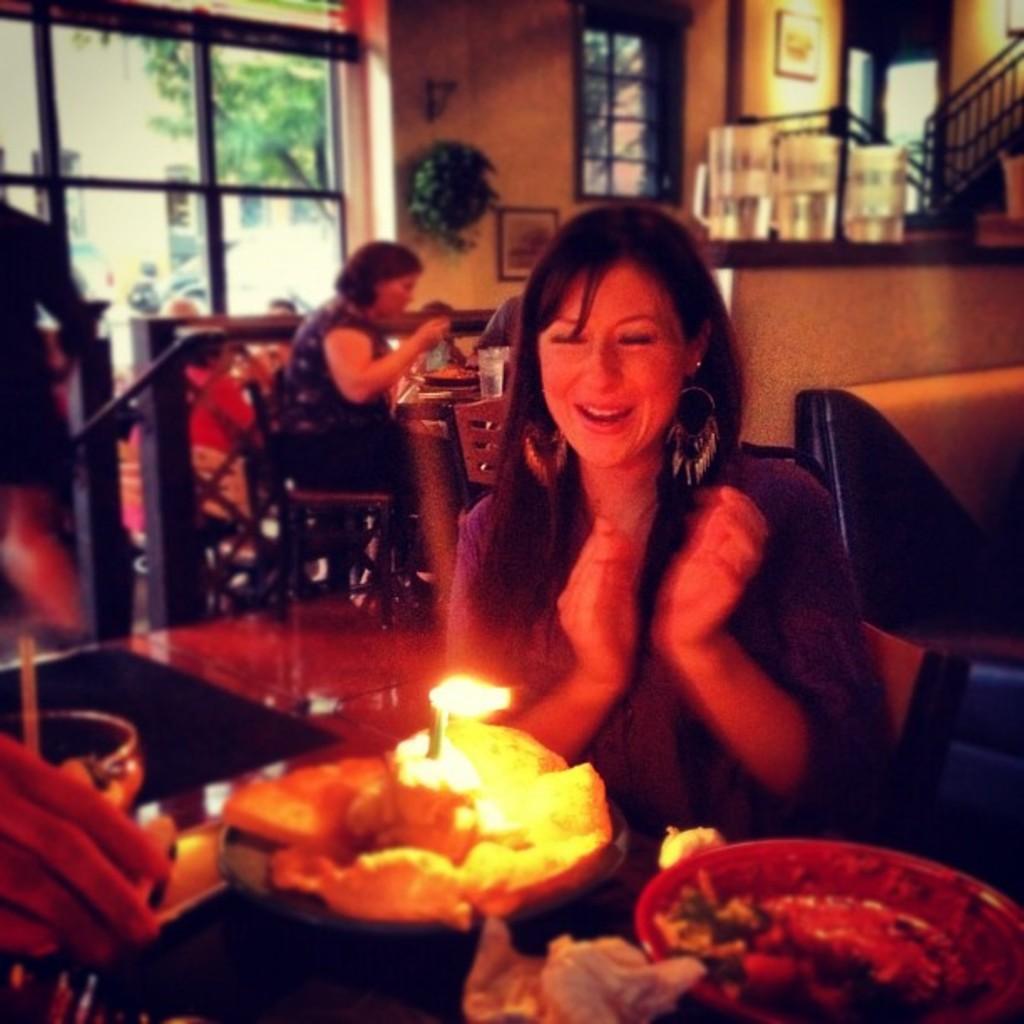Can you describe this image briefly? In this picture we can see a woman is sitting and smiling, and in front here is the table and cake and some objects on it, and at back here another person is sitting, and here is the window. 